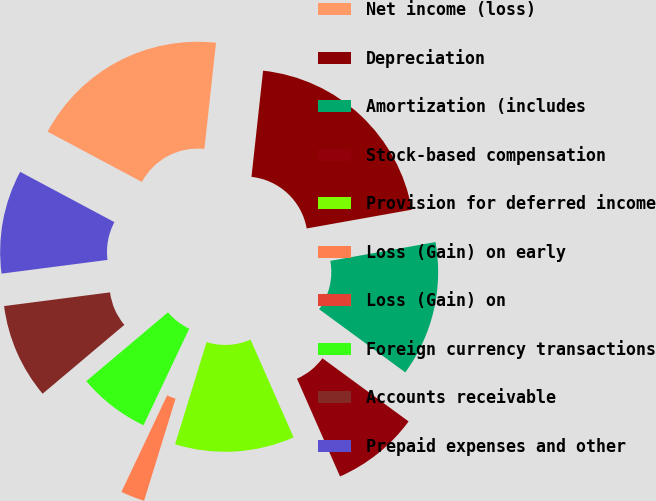<chart> <loc_0><loc_0><loc_500><loc_500><pie_chart><fcel>Net income (loss)<fcel>Depreciation<fcel>Amortization (includes<fcel>Stock-based compensation<fcel>Provision for deferred income<fcel>Loss (Gain) on early<fcel>Loss (Gain) on<fcel>Foreign currency transactions<fcel>Accounts receivable<fcel>Prepaid expenses and other<nl><fcel>18.93%<fcel>20.45%<fcel>12.88%<fcel>8.33%<fcel>11.36%<fcel>2.28%<fcel>0.0%<fcel>6.82%<fcel>9.09%<fcel>9.85%<nl></chart> 